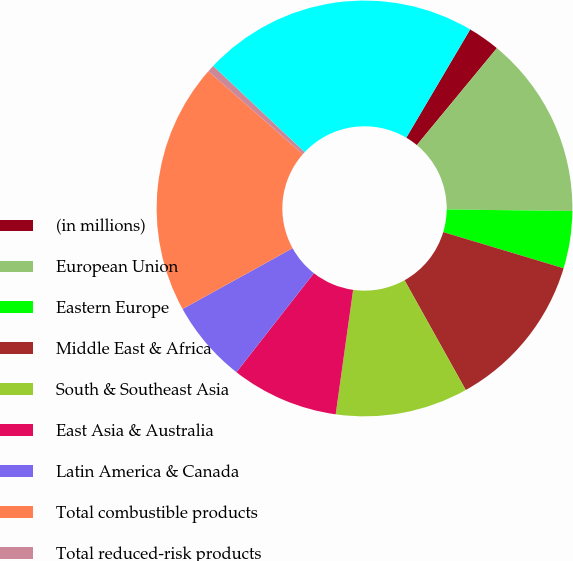Convert chart to OTSL. <chart><loc_0><loc_0><loc_500><loc_500><pie_chart><fcel>(in millions)<fcel>European Union<fcel>Eastern Europe<fcel>Middle East & Africa<fcel>South & Southeast Asia<fcel>East Asia & Australia<fcel>Latin America & Canada<fcel>Total combustible products<fcel>Total reduced-risk products<fcel>Total PMI net revenues<nl><fcel>2.5%<fcel>14.21%<fcel>4.45%<fcel>12.26%<fcel>10.31%<fcel>8.35%<fcel>6.4%<fcel>19.51%<fcel>0.55%<fcel>21.46%<nl></chart> 